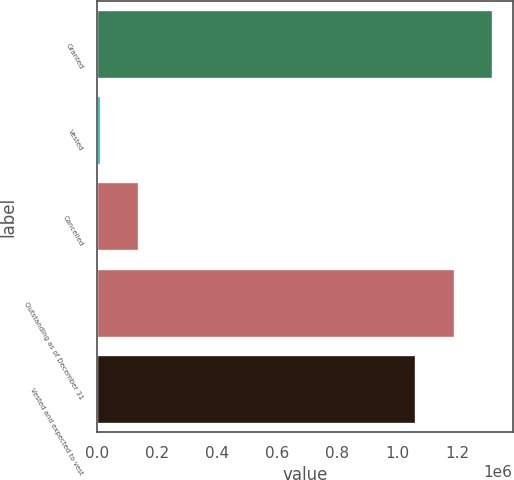<chart> <loc_0><loc_0><loc_500><loc_500><bar_chart><fcel>Granted<fcel>Vested<fcel>Cancelled<fcel>Outstanding as of December 31<fcel>Vested and expected to vest<nl><fcel>1.31748e+06<fcel>11440<fcel>138877<fcel>1.19005e+06<fcel>1.06261e+06<nl></chart> 